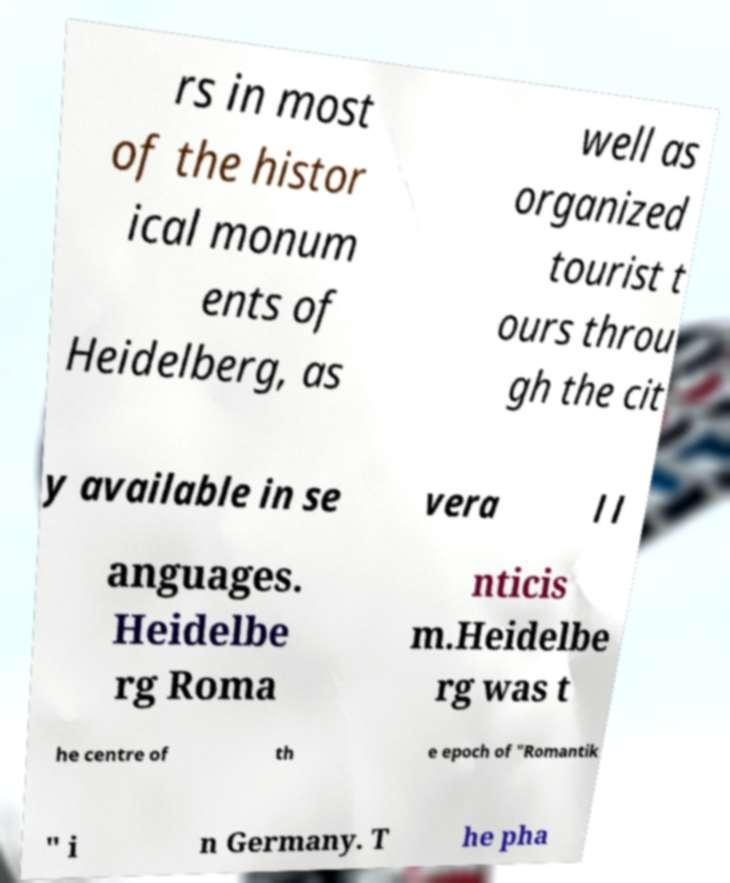Can you accurately transcribe the text from the provided image for me? rs in most of the histor ical monum ents of Heidelberg, as well as organized tourist t ours throu gh the cit y available in se vera l l anguages. Heidelbe rg Roma nticis m.Heidelbe rg was t he centre of th e epoch of "Romantik " i n Germany. T he pha 